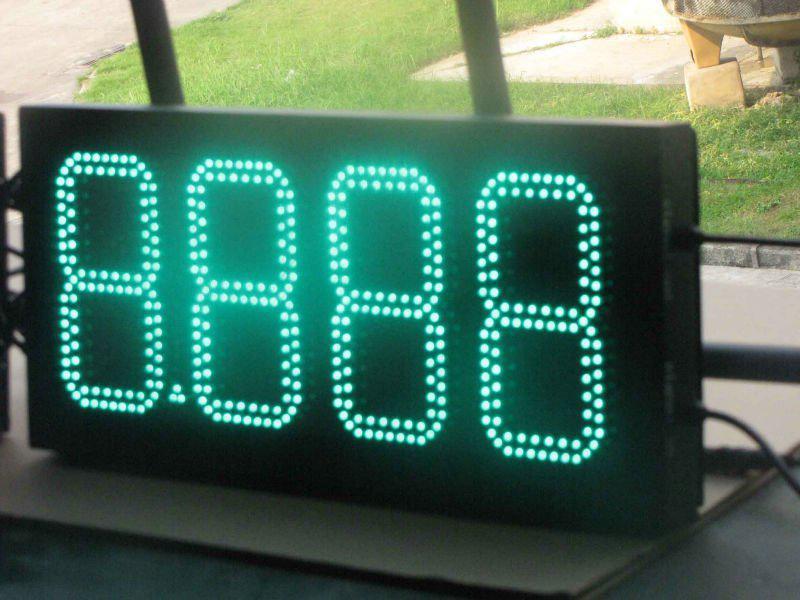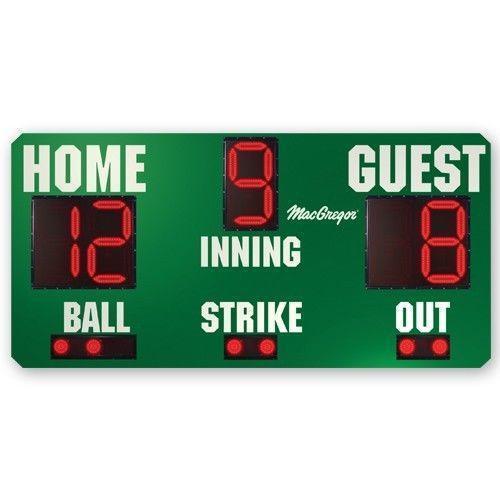The first image is the image on the left, the second image is the image on the right. Considering the images on both sides, is "There are two scoreboards which list the home score on the left side and the guest score on the right side." valid? Answer yes or no. No. 